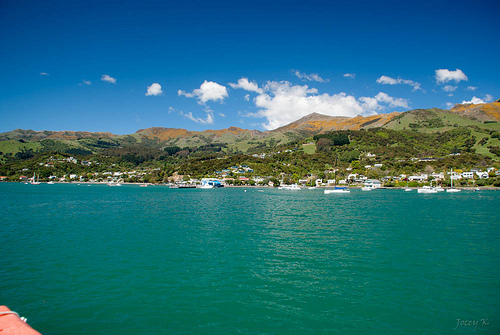<image>
Is there a trees on the mountain? Yes. Looking at the image, I can see the trees is positioned on top of the mountain, with the mountain providing support. 